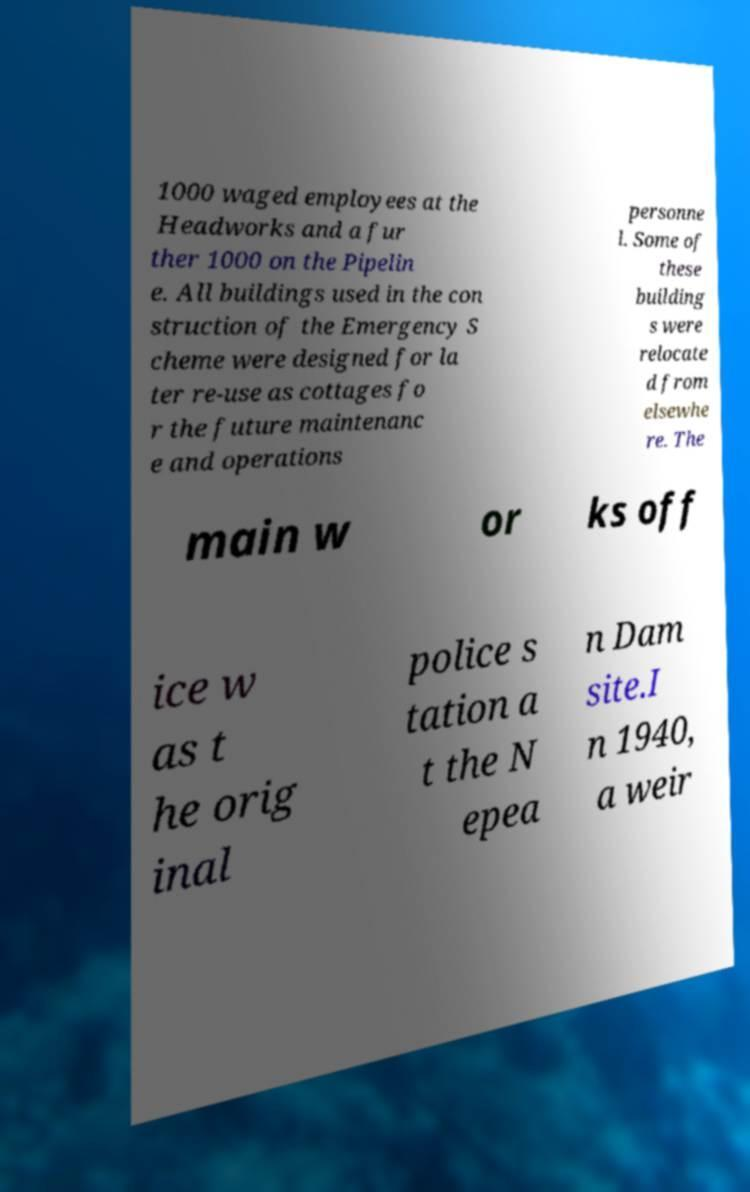I need the written content from this picture converted into text. Can you do that? 1000 waged employees at the Headworks and a fur ther 1000 on the Pipelin e. All buildings used in the con struction of the Emergency S cheme were designed for la ter re-use as cottages fo r the future maintenanc e and operations personne l. Some of these building s were relocate d from elsewhe re. The main w or ks off ice w as t he orig inal police s tation a t the N epea n Dam site.I n 1940, a weir 